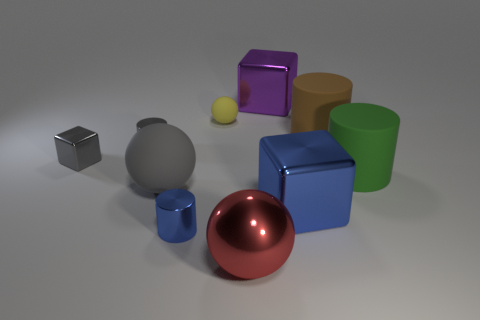Subtract all balls. How many objects are left? 7 Add 7 small matte objects. How many small matte objects exist? 8 Subtract 1 gray cylinders. How many objects are left? 9 Subtract all large matte cylinders. Subtract all tiny blue metallic objects. How many objects are left? 7 Add 1 small blue things. How many small blue things are left? 2 